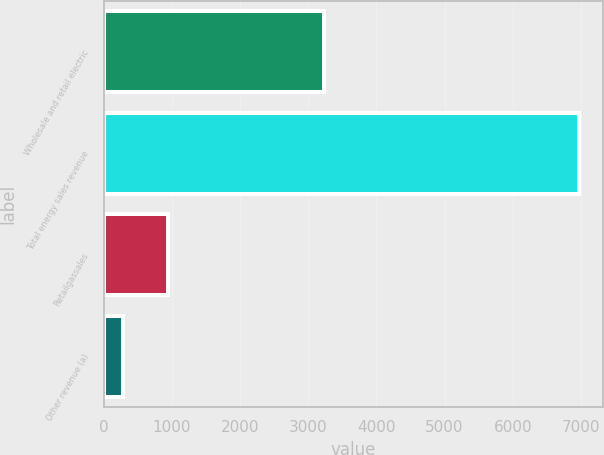Convert chart. <chart><loc_0><loc_0><loc_500><loc_500><bar_chart><fcel>Wholesale and retail electric<fcel>Total energy sales revenue<fcel>Retailgassales<fcel>Other revenue (a)<nl><fcel>3227<fcel>6976<fcel>948.7<fcel>279<nl></chart> 